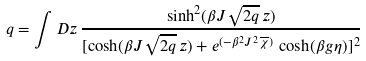<formula> <loc_0><loc_0><loc_500><loc_500>q = \int D z \, \frac { \sinh ^ { 2 } ( \beta J \sqrt { 2 q } \, z ) } { [ \cosh ( \beta J \sqrt { 2 q } \, z ) + e ^ { ( - \beta ^ { 2 } J ^ { 2 } \, \overline { \chi } ) } \, \cosh ( \beta g \eta ) ] ^ { 2 } }</formula> 